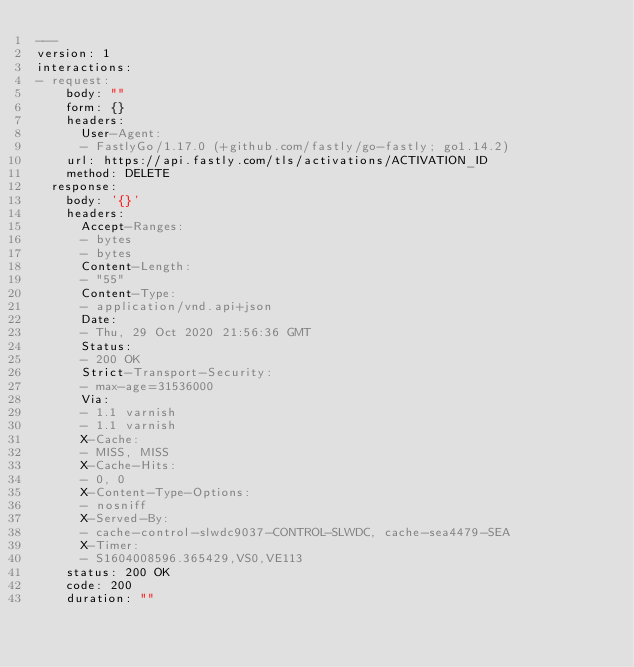Convert code to text. <code><loc_0><loc_0><loc_500><loc_500><_YAML_>---
version: 1
interactions:
- request:
    body: ""
    form: {}
    headers:
      User-Agent:
      - FastlyGo/1.17.0 (+github.com/fastly/go-fastly; go1.14.2)
    url: https://api.fastly.com/tls/activations/ACTIVATION_ID
    method: DELETE
  response:
    body: '{}'
    headers:
      Accept-Ranges:
      - bytes
      - bytes
      Content-Length:
      - "55"
      Content-Type:
      - application/vnd.api+json
      Date:
      - Thu, 29 Oct 2020 21:56:36 GMT
      Status:
      - 200 OK
      Strict-Transport-Security:
      - max-age=31536000
      Via:
      - 1.1 varnish
      - 1.1 varnish
      X-Cache:
      - MISS, MISS
      X-Cache-Hits:
      - 0, 0
      X-Content-Type-Options:
      - nosniff
      X-Served-By:
      - cache-control-slwdc9037-CONTROL-SLWDC, cache-sea4479-SEA
      X-Timer:
      - S1604008596.365429,VS0,VE113
    status: 200 OK
    code: 200
    duration: ""
</code> 